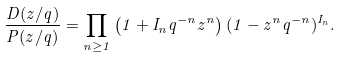Convert formula to latex. <formula><loc_0><loc_0><loc_500><loc_500>\frac { D ( z / q ) } { P ( z / q ) } = \prod _ { n \geq 1 } \left ( 1 + I _ { n } q ^ { - n } z ^ { n } \right ) ( 1 - z ^ { n } q ^ { - n } ) ^ { I _ { n } } .</formula> 